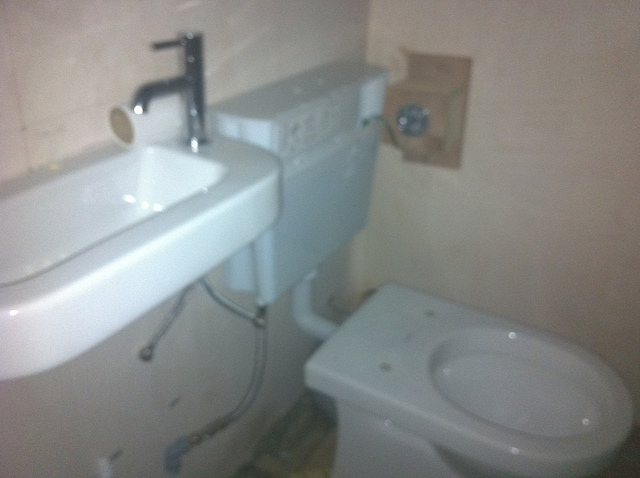Is this a new bathroom? It does not appear to be new; on the contrary, the bathroom fixtures and walls show signs of wear and aging. 